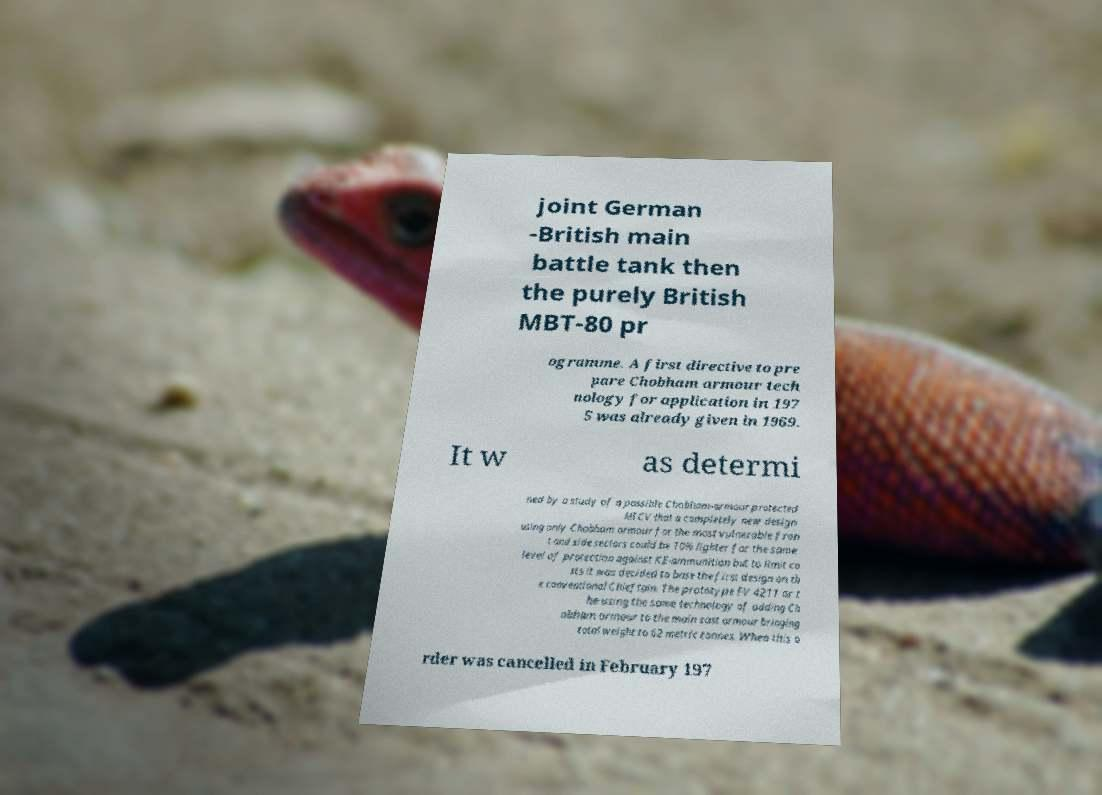Can you accurately transcribe the text from the provided image for me? joint German -British main battle tank then the purely British MBT-80 pr ogramme. A first directive to pre pare Chobham armour tech nology for application in 197 5 was already given in 1969. It w as determi ned by a study of a possible Chobham-armour protected MICV that a completely new design using only Chobham armour for the most vulnerable fron t and side sectors could be 10% lighter for the same level of protection against KE-ammunition but to limit co sts it was decided to base the first design on th e conventional Chieftain. The prototype FV 4211 or t he using the same technology of adding Ch obham armour to the main cast armour bringing total weight to 62 metric tonnes. When this o rder was cancelled in February 197 